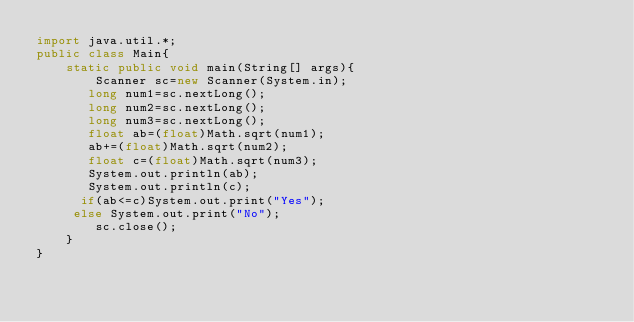<code> <loc_0><loc_0><loc_500><loc_500><_Java_>import java.util.*; 
public class Main{
    static public void main(String[] args){
        Scanner sc=new Scanner(System.in);
       long num1=sc.nextLong();
       long num2=sc.nextLong();
       long num3=sc.nextLong();
       float ab=(float)Math.sqrt(num1);
       ab+=(float)Math.sqrt(num2);
       float c=(float)Math.sqrt(num3);
       System.out.println(ab);
       System.out.println(c);
      if(ab<=c)System.out.print("Yes");
     else System.out.print("No");
        sc.close();
    }
}</code> 